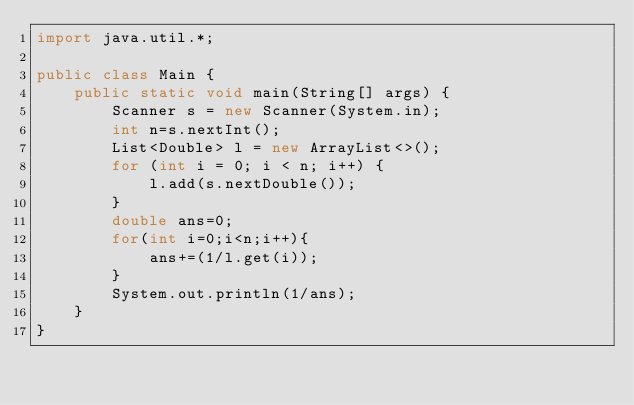<code> <loc_0><loc_0><loc_500><loc_500><_Java_>import java.util.*;

public class Main {
    public static void main(String[] args) {
        Scanner s = new Scanner(System.in);
        int n=s.nextInt();
        List<Double> l = new ArrayList<>();
        for (int i = 0; i < n; i++) {
            l.add(s.nextDouble());
        }
        double ans=0;
        for(int i=0;i<n;i++){
            ans+=(1/l.get(i));
        }
        System.out.println(1/ans);
    }
}</code> 